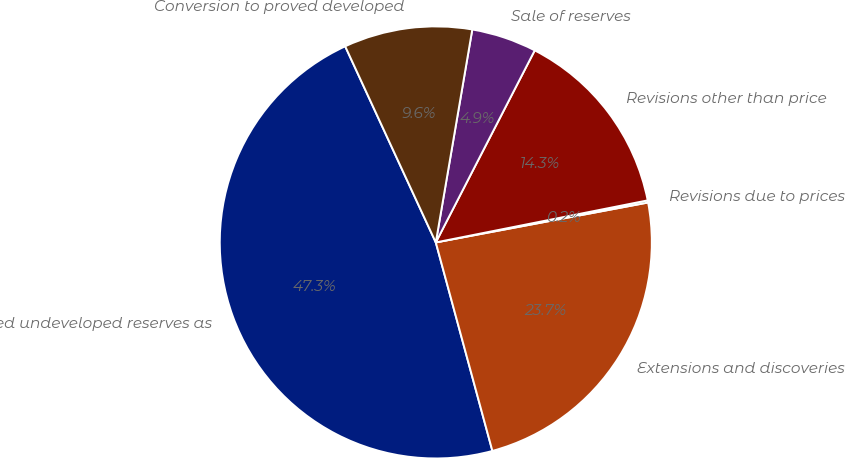<chart> <loc_0><loc_0><loc_500><loc_500><pie_chart><fcel>Proved undeveloped reserves as<fcel>Extensions and discoveries<fcel>Revisions due to prices<fcel>Revisions other than price<fcel>Sale of reserves<fcel>Conversion to proved developed<nl><fcel>47.33%<fcel>23.74%<fcel>0.16%<fcel>14.31%<fcel>4.87%<fcel>9.59%<nl></chart> 